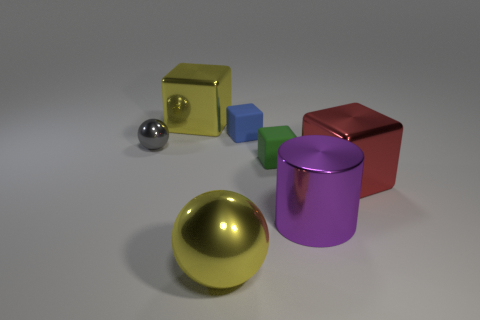Are there any purple things that have the same shape as the green matte object?
Ensure brevity in your answer.  No. There is a big yellow thing that is to the left of the big yellow metallic object that is in front of the gray metallic thing; what shape is it?
Keep it short and to the point. Cube. The yellow metallic object that is in front of the tiny metallic sphere has what shape?
Give a very brief answer. Sphere. There is a large metallic cube in front of the tiny green cube; is it the same color as the big object that is left of the yellow ball?
Keep it short and to the point. No. What number of large blocks are both left of the red shiny cube and in front of the tiny gray ball?
Provide a short and direct response. 0. There is a green thing that is made of the same material as the blue thing; what is its size?
Your answer should be very brief. Small. What size is the blue rubber cube?
Keep it short and to the point. Small. What material is the red cube?
Ensure brevity in your answer.  Metal. There is a yellow object that is on the left side of the yellow sphere; is it the same size as the large purple thing?
Ensure brevity in your answer.  Yes. What number of things are tiny red matte cubes or purple things?
Keep it short and to the point. 1. 